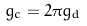Convert formula to latex. <formula><loc_0><loc_0><loc_500><loc_500>g _ { c } = 2 \pi g _ { d }</formula> 